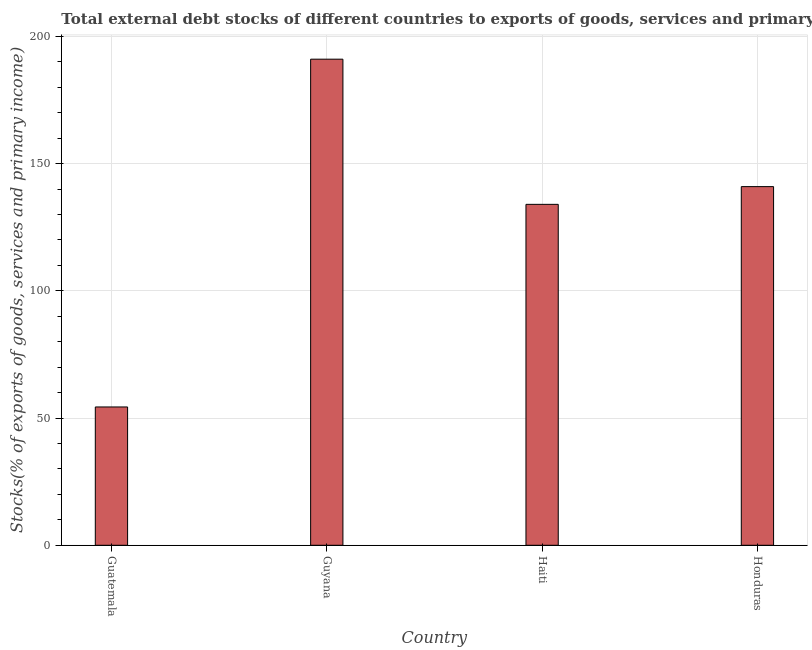Does the graph contain grids?
Your response must be concise. Yes. What is the title of the graph?
Provide a succinct answer. Total external debt stocks of different countries to exports of goods, services and primary income in 1977. What is the label or title of the X-axis?
Provide a succinct answer. Country. What is the label or title of the Y-axis?
Keep it short and to the point. Stocks(% of exports of goods, services and primary income). What is the external debt stocks in Haiti?
Your answer should be very brief. 134. Across all countries, what is the maximum external debt stocks?
Ensure brevity in your answer.  191.07. Across all countries, what is the minimum external debt stocks?
Provide a succinct answer. 54.37. In which country was the external debt stocks maximum?
Make the answer very short. Guyana. In which country was the external debt stocks minimum?
Offer a very short reply. Guatemala. What is the sum of the external debt stocks?
Your answer should be compact. 520.42. What is the difference between the external debt stocks in Guatemala and Guyana?
Keep it short and to the point. -136.7. What is the average external debt stocks per country?
Your answer should be very brief. 130.1. What is the median external debt stocks?
Offer a terse response. 137.49. What is the ratio of the external debt stocks in Guatemala to that in Honduras?
Make the answer very short. 0.39. Is the difference between the external debt stocks in Guyana and Honduras greater than the difference between any two countries?
Offer a terse response. No. What is the difference between the highest and the second highest external debt stocks?
Give a very brief answer. 50.09. What is the difference between the highest and the lowest external debt stocks?
Make the answer very short. 136.7. In how many countries, is the external debt stocks greater than the average external debt stocks taken over all countries?
Your response must be concise. 3. Are all the bars in the graph horizontal?
Provide a succinct answer. No. How many countries are there in the graph?
Your answer should be compact. 4. What is the Stocks(% of exports of goods, services and primary income) in Guatemala?
Your response must be concise. 54.37. What is the Stocks(% of exports of goods, services and primary income) in Guyana?
Ensure brevity in your answer.  191.07. What is the Stocks(% of exports of goods, services and primary income) in Haiti?
Provide a succinct answer. 134. What is the Stocks(% of exports of goods, services and primary income) of Honduras?
Your answer should be very brief. 140.98. What is the difference between the Stocks(% of exports of goods, services and primary income) in Guatemala and Guyana?
Provide a succinct answer. -136.7. What is the difference between the Stocks(% of exports of goods, services and primary income) in Guatemala and Haiti?
Give a very brief answer. -79.64. What is the difference between the Stocks(% of exports of goods, services and primary income) in Guatemala and Honduras?
Keep it short and to the point. -86.61. What is the difference between the Stocks(% of exports of goods, services and primary income) in Guyana and Haiti?
Offer a terse response. 57.07. What is the difference between the Stocks(% of exports of goods, services and primary income) in Guyana and Honduras?
Make the answer very short. 50.09. What is the difference between the Stocks(% of exports of goods, services and primary income) in Haiti and Honduras?
Offer a very short reply. -6.97. What is the ratio of the Stocks(% of exports of goods, services and primary income) in Guatemala to that in Guyana?
Give a very brief answer. 0.28. What is the ratio of the Stocks(% of exports of goods, services and primary income) in Guatemala to that in Haiti?
Keep it short and to the point. 0.41. What is the ratio of the Stocks(% of exports of goods, services and primary income) in Guatemala to that in Honduras?
Provide a succinct answer. 0.39. What is the ratio of the Stocks(% of exports of goods, services and primary income) in Guyana to that in Haiti?
Ensure brevity in your answer.  1.43. What is the ratio of the Stocks(% of exports of goods, services and primary income) in Guyana to that in Honduras?
Keep it short and to the point. 1.35. What is the ratio of the Stocks(% of exports of goods, services and primary income) in Haiti to that in Honduras?
Your answer should be very brief. 0.95. 